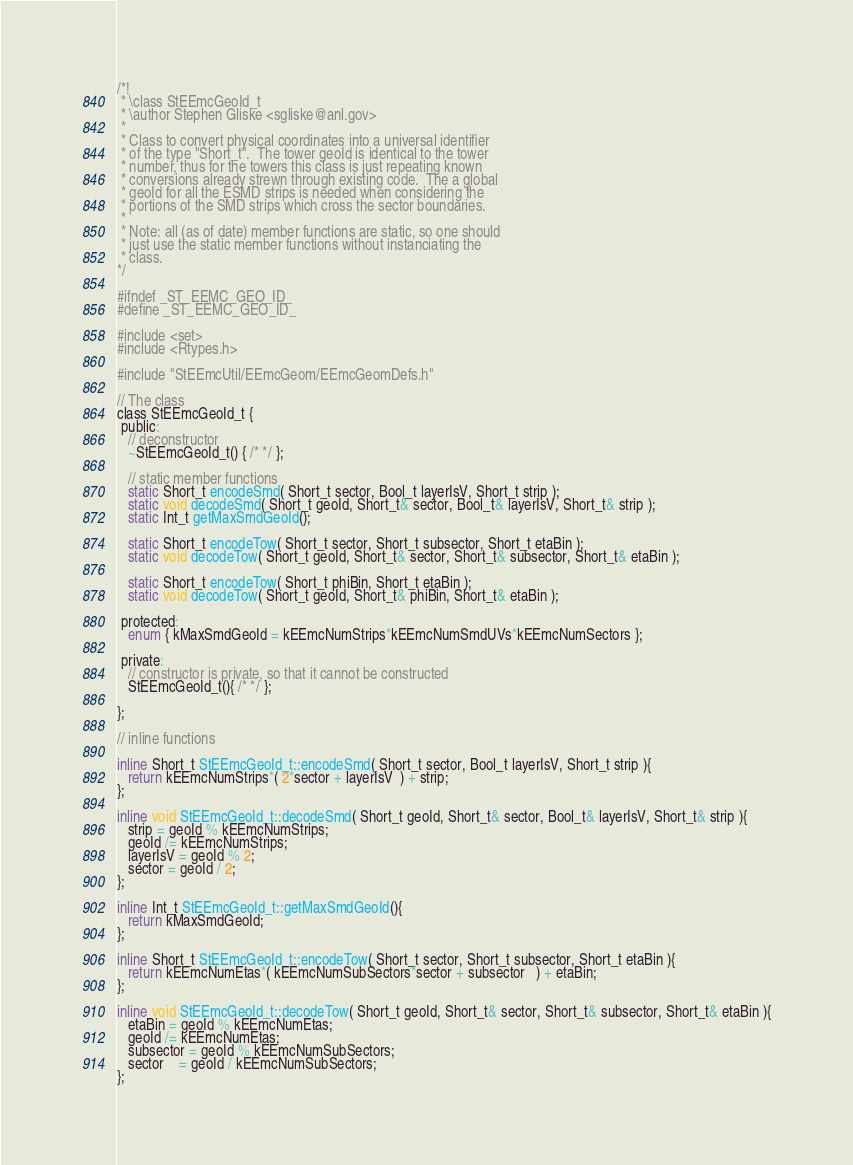Convert code to text. <code><loc_0><loc_0><loc_500><loc_500><_C_>/*!
 * \class StEEmcGeoId_t
 * \author Stephen Gliske <sgliske@anl.gov>
 *
 * Class to convert physical coordinates into a universal identifier
 * of the type "Short_t".  The tower geoId is identical to the tower
 * number, thus for the towers this class is just repeating known
 * conversions already strewn through existing code.  The a global
 * geoId for all the ESMD strips is needed when considering the
 * portions of the SMD strips which cross the sector boundaries.
 *
 * Note: all (as of date) member functions are static, so one should
 * just use the static member functions without instanciating the
 * class.
*/

#ifndef _ST_EEMC_GEO_ID_
#define _ST_EEMC_GEO_ID_

#include <set>
#include <Rtypes.h>

#include "StEEmcUtil/EEmcGeom/EEmcGeomDefs.h"

// The class
class StEEmcGeoId_t {
 public:
   // deconstructor
   ~StEEmcGeoId_t() { /* */ };

   // static member functions
   static Short_t encodeSmd( Short_t sector, Bool_t layerIsV, Short_t strip );
   static void decodeSmd( Short_t geoId, Short_t& sector, Bool_t& layerIsV, Short_t& strip );
   static Int_t getMaxSmdGeoId();

   static Short_t encodeTow( Short_t sector, Short_t subsector, Short_t etaBin );
   static void decodeTow( Short_t geoId, Short_t& sector, Short_t& subsector, Short_t& etaBin );

   static Short_t encodeTow( Short_t phiBin, Short_t etaBin );
   static void decodeTow( Short_t geoId, Short_t& phiBin, Short_t& etaBin );

 protected:
   enum { kMaxSmdGeoId = kEEmcNumStrips*kEEmcNumSmdUVs*kEEmcNumSectors };

 private:
   // constructor is private, so that it cannot be constructed
   StEEmcGeoId_t(){ /* */ };

};

// inline functions

inline Short_t StEEmcGeoId_t::encodeSmd( Short_t sector, Bool_t layerIsV, Short_t strip ){
   return kEEmcNumStrips*( 2*sector + layerIsV  ) + strip;
};

inline void StEEmcGeoId_t::decodeSmd( Short_t geoId, Short_t& sector, Bool_t& layerIsV, Short_t& strip ){
   strip = geoId % kEEmcNumStrips;
   geoId /= kEEmcNumStrips;
   layerIsV = geoId % 2;
   sector = geoId / 2;
};

inline Int_t StEEmcGeoId_t::getMaxSmdGeoId(){
   return kMaxSmdGeoId;
};

inline Short_t StEEmcGeoId_t::encodeTow( Short_t sector, Short_t subsector, Short_t etaBin ){
   return kEEmcNumEtas*( kEEmcNumSubSectors*sector + subsector   ) + etaBin;
};

inline void StEEmcGeoId_t::decodeTow( Short_t geoId, Short_t& sector, Short_t& subsector, Short_t& etaBin ){
   etaBin = geoId % kEEmcNumEtas;
   geoId /= kEEmcNumEtas;
   subsector = geoId % kEEmcNumSubSectors;
   sector    = geoId / kEEmcNumSubSectors;
};
</code> 